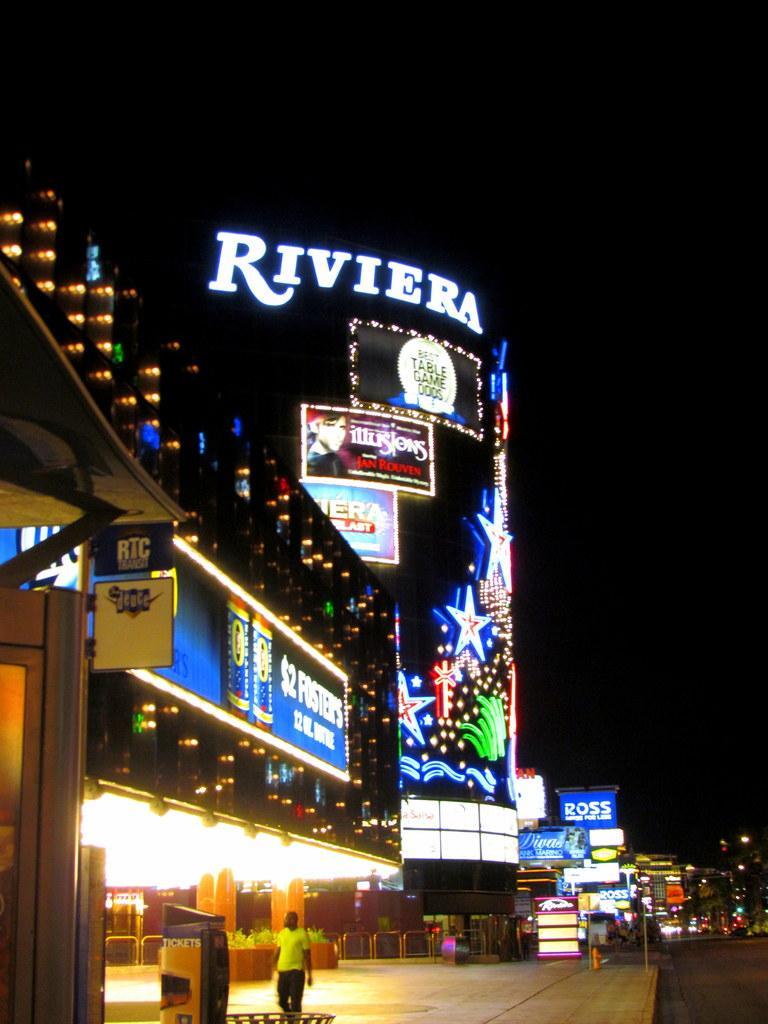Can you describe this image briefly? This picture is clicked outside. In the foreground we can see a person seems to be walking on the ground. On the left we can see an object. In the center we can see an object seems to be a water hydrant and we can see the text on the boards and we can see the text and pictures on the building, we can see the decoration lights. In the background we can see the sky, buildings, lights and many other objects. 